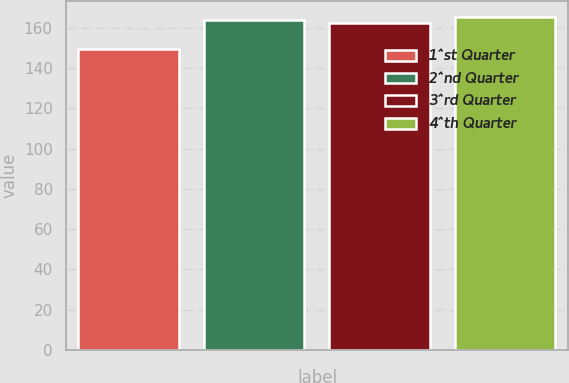Convert chart. <chart><loc_0><loc_0><loc_500><loc_500><bar_chart><fcel>1^st Quarter<fcel>2^nd Quarter<fcel>3^rd Quarter<fcel>4^th Quarter<nl><fcel>149.6<fcel>163.81<fcel>162.43<fcel>165.19<nl></chart> 